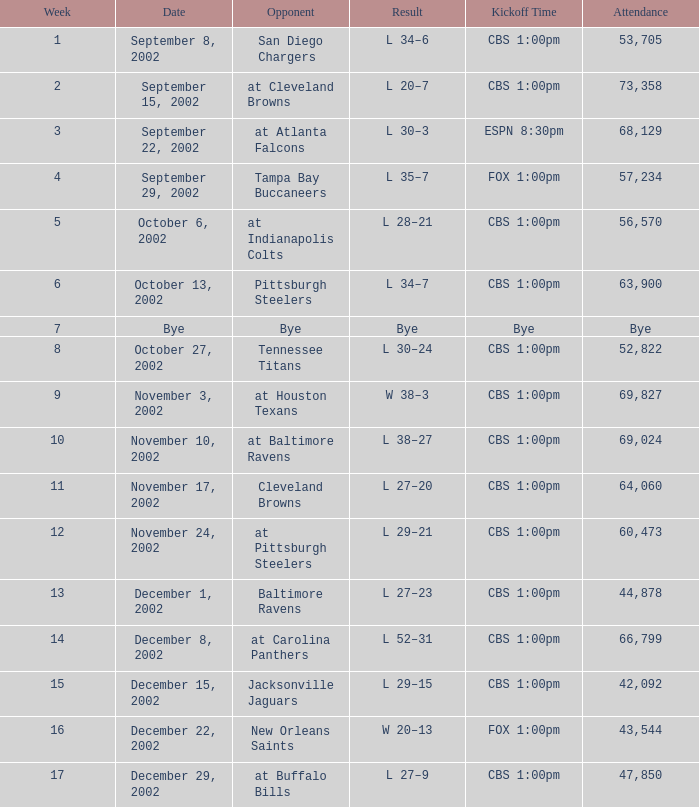What is the upshot of the game with a crowd of 57,234 people? L 35–7. 